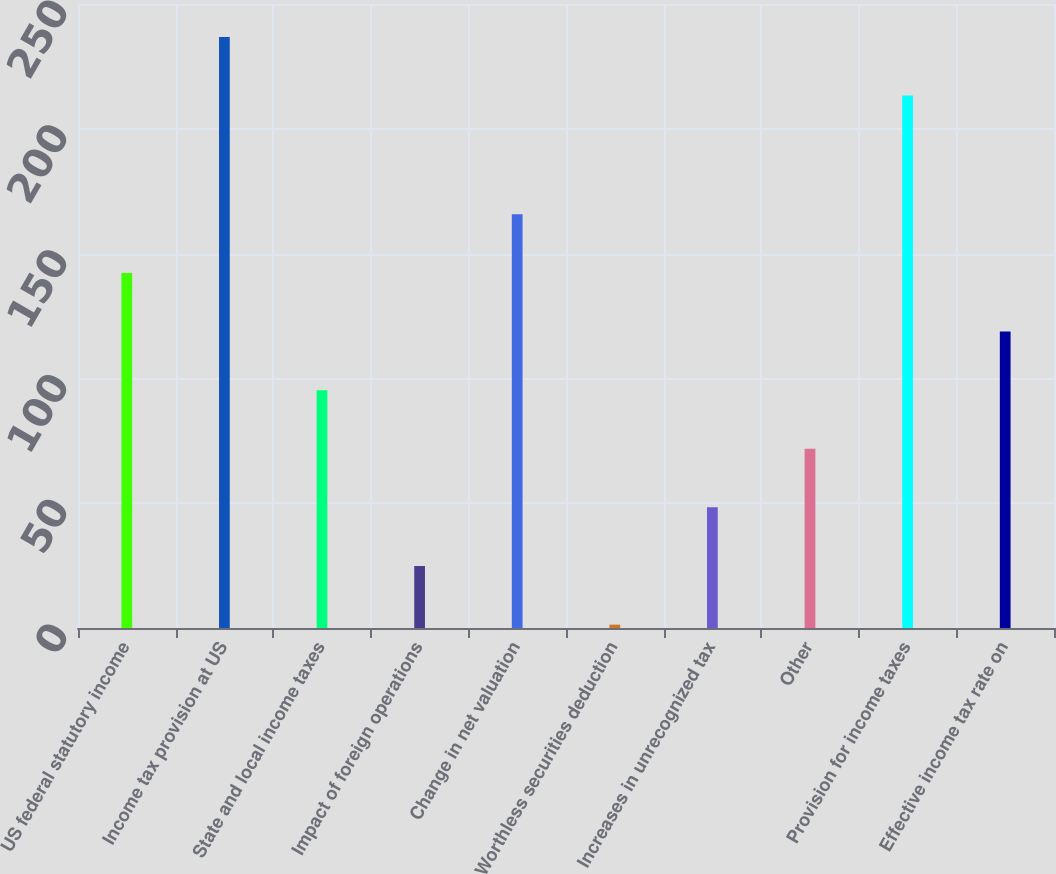Convert chart to OTSL. <chart><loc_0><loc_0><loc_500><loc_500><bar_chart><fcel>US federal statutory income<fcel>Income tax provision at US<fcel>State and local income taxes<fcel>Impact of foreign operations<fcel>Change in net valuation<fcel>Worthless securities deduction<fcel>Increases in unrecognized tax<fcel>Other<fcel>Provision for income taxes<fcel>Effective income tax rate on<nl><fcel>142.26<fcel>236.79<fcel>95.3<fcel>24.84<fcel>165.75<fcel>1.35<fcel>48.33<fcel>71.81<fcel>213.3<fcel>118.78<nl></chart> 